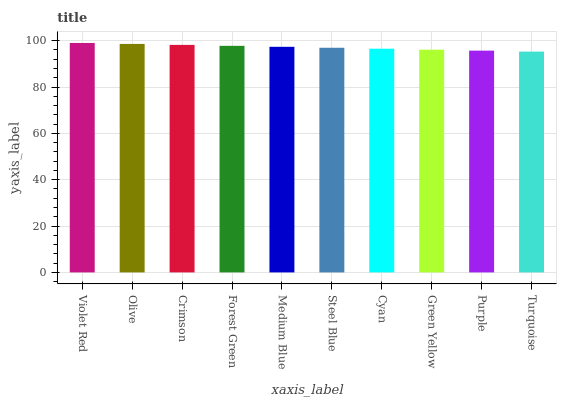Is Olive the minimum?
Answer yes or no. No. Is Olive the maximum?
Answer yes or no. No. Is Violet Red greater than Olive?
Answer yes or no. Yes. Is Olive less than Violet Red?
Answer yes or no. Yes. Is Olive greater than Violet Red?
Answer yes or no. No. Is Violet Red less than Olive?
Answer yes or no. No. Is Medium Blue the high median?
Answer yes or no. Yes. Is Steel Blue the low median?
Answer yes or no. Yes. Is Crimson the high median?
Answer yes or no. No. Is Olive the low median?
Answer yes or no. No. 